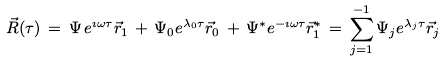<formula> <loc_0><loc_0><loc_500><loc_500>\vec { R } ( \tau ) \, = \, \Psi \, e ^ { \imath \omega \tau } \vec { r } _ { 1 } \, + \, \Psi _ { 0 } e ^ { \lambda _ { 0 } \tau } \vec { r } _ { 0 } \, + \, \Psi ^ { * } e ^ { - \imath \omega \tau } \vec { r } _ { 1 } ^ { * } \, = \, \sum ^ { - 1 } _ { j = 1 } \Psi _ { j } e ^ { \lambda _ { j } \tau } \vec { r } _ { j }</formula> 